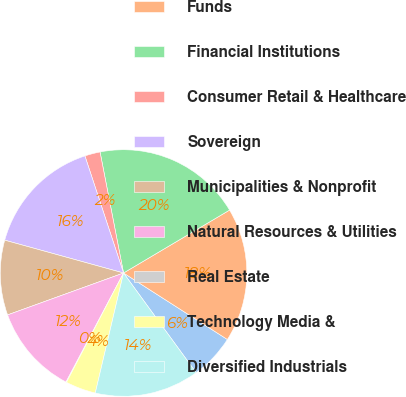Convert chart to OTSL. <chart><loc_0><loc_0><loc_500><loc_500><pie_chart><fcel>in millions<fcel>Funds<fcel>Financial Institutions<fcel>Consumer Retail & Healthcare<fcel>Sovereign<fcel>Municipalities & Nonprofit<fcel>Natural Resources & Utilities<fcel>Real Estate<fcel>Technology Media &<fcel>Diversified Industrials<nl><fcel>5.92%<fcel>17.59%<fcel>19.53%<fcel>2.02%<fcel>15.64%<fcel>9.81%<fcel>11.75%<fcel>0.08%<fcel>3.97%<fcel>13.7%<nl></chart> 